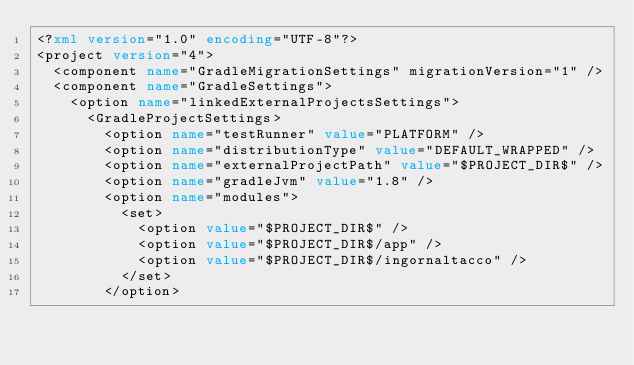Convert code to text. <code><loc_0><loc_0><loc_500><loc_500><_XML_><?xml version="1.0" encoding="UTF-8"?>
<project version="4">
  <component name="GradleMigrationSettings" migrationVersion="1" />
  <component name="GradleSettings">
    <option name="linkedExternalProjectsSettings">
      <GradleProjectSettings>
        <option name="testRunner" value="PLATFORM" />
        <option name="distributionType" value="DEFAULT_WRAPPED" />
        <option name="externalProjectPath" value="$PROJECT_DIR$" />
        <option name="gradleJvm" value="1.8" />
        <option name="modules">
          <set>
            <option value="$PROJECT_DIR$" />
            <option value="$PROJECT_DIR$/app" />
            <option value="$PROJECT_DIR$/ingornaltacco" />
          </set>
        </option></code> 